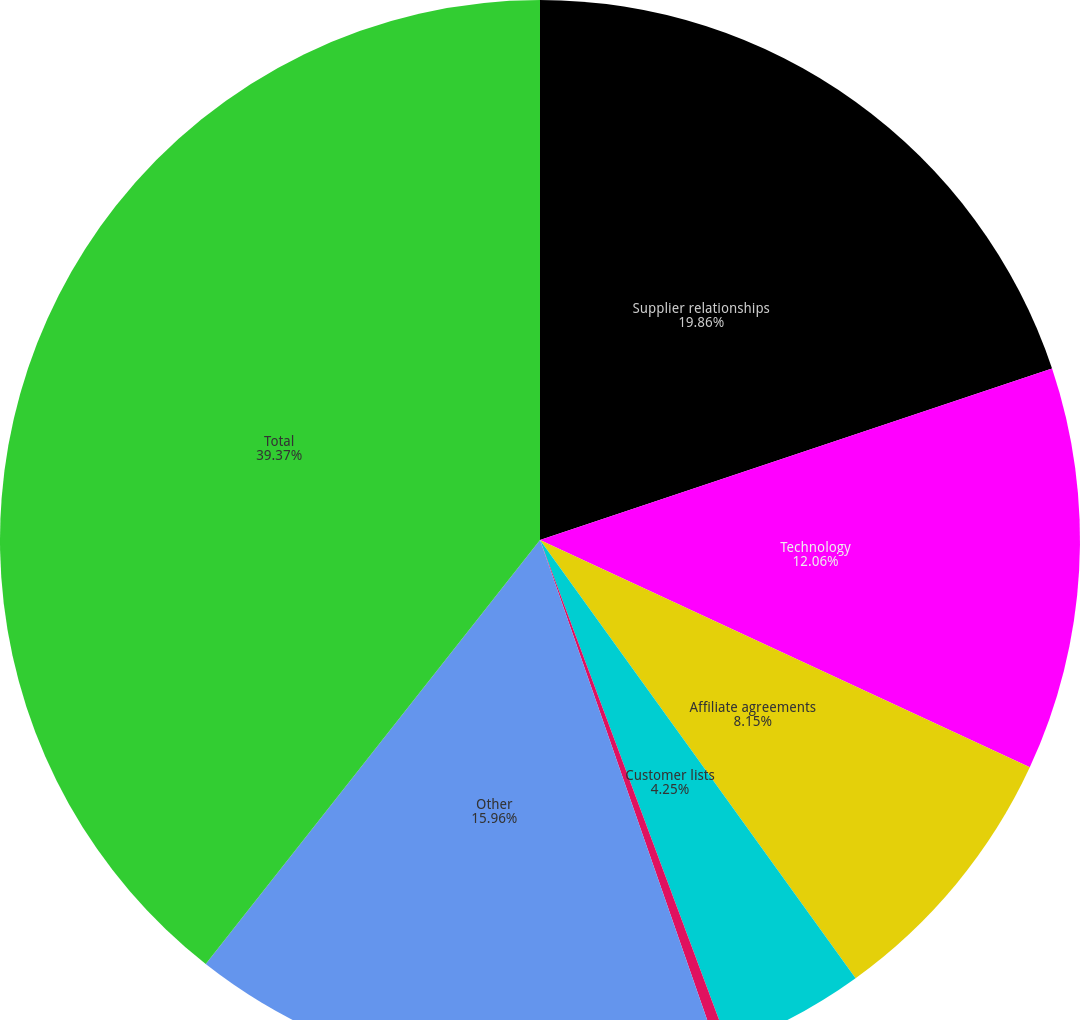Convert chart. <chart><loc_0><loc_0><loc_500><loc_500><pie_chart><fcel>Supplier relationships<fcel>Technology<fcel>Affiliate agreements<fcel>Customer lists<fcel>Domain names<fcel>Other<fcel>Total<nl><fcel>19.86%<fcel>12.06%<fcel>8.15%<fcel>4.25%<fcel>0.35%<fcel>15.96%<fcel>39.38%<nl></chart> 